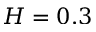<formula> <loc_0><loc_0><loc_500><loc_500>H = 0 . 3</formula> 